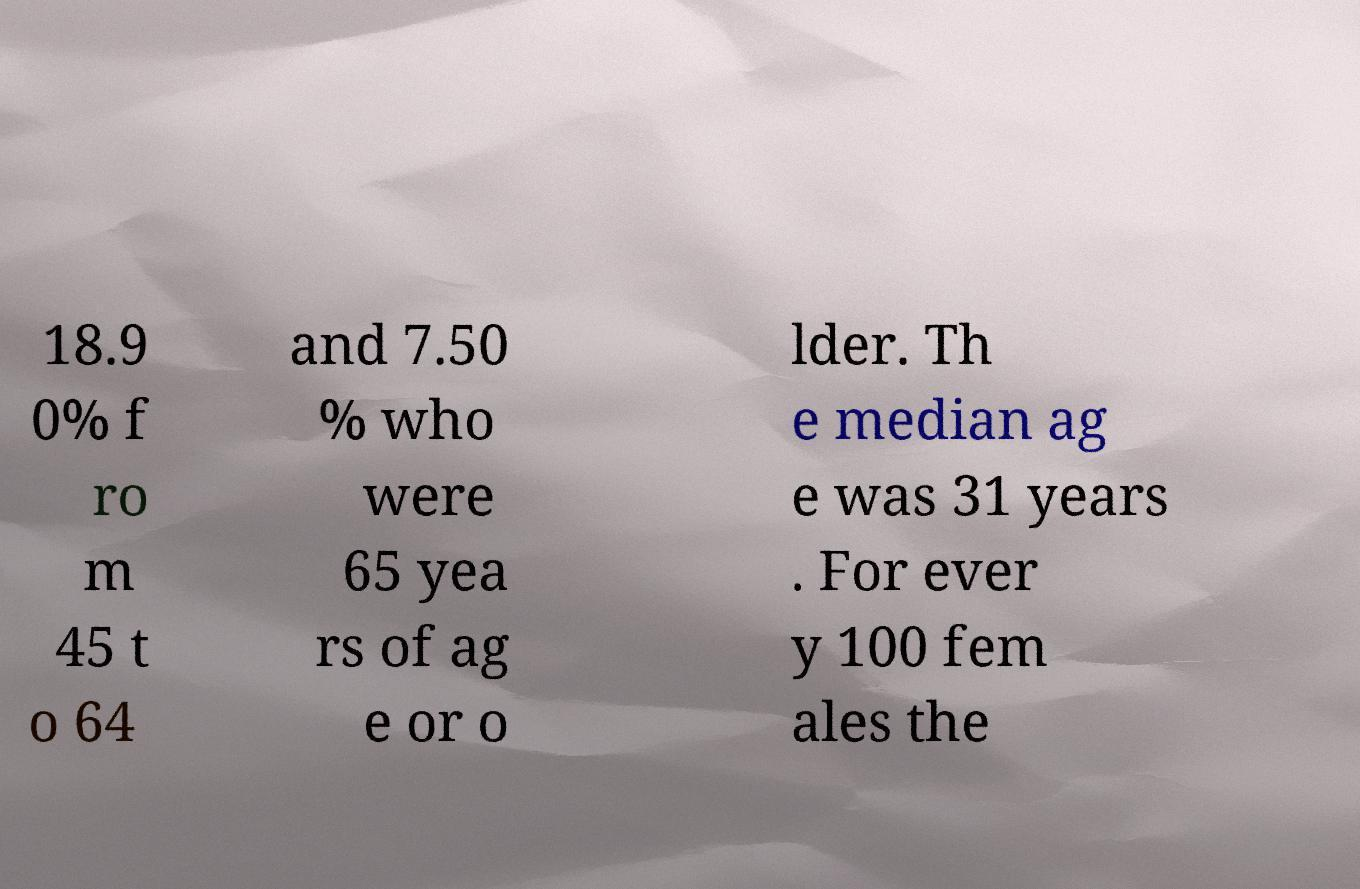Can you read and provide the text displayed in the image?This photo seems to have some interesting text. Can you extract and type it out for me? 18.9 0% f ro m 45 t o 64 and 7.50 % who were 65 yea rs of ag e or o lder. Th e median ag e was 31 years . For ever y 100 fem ales the 